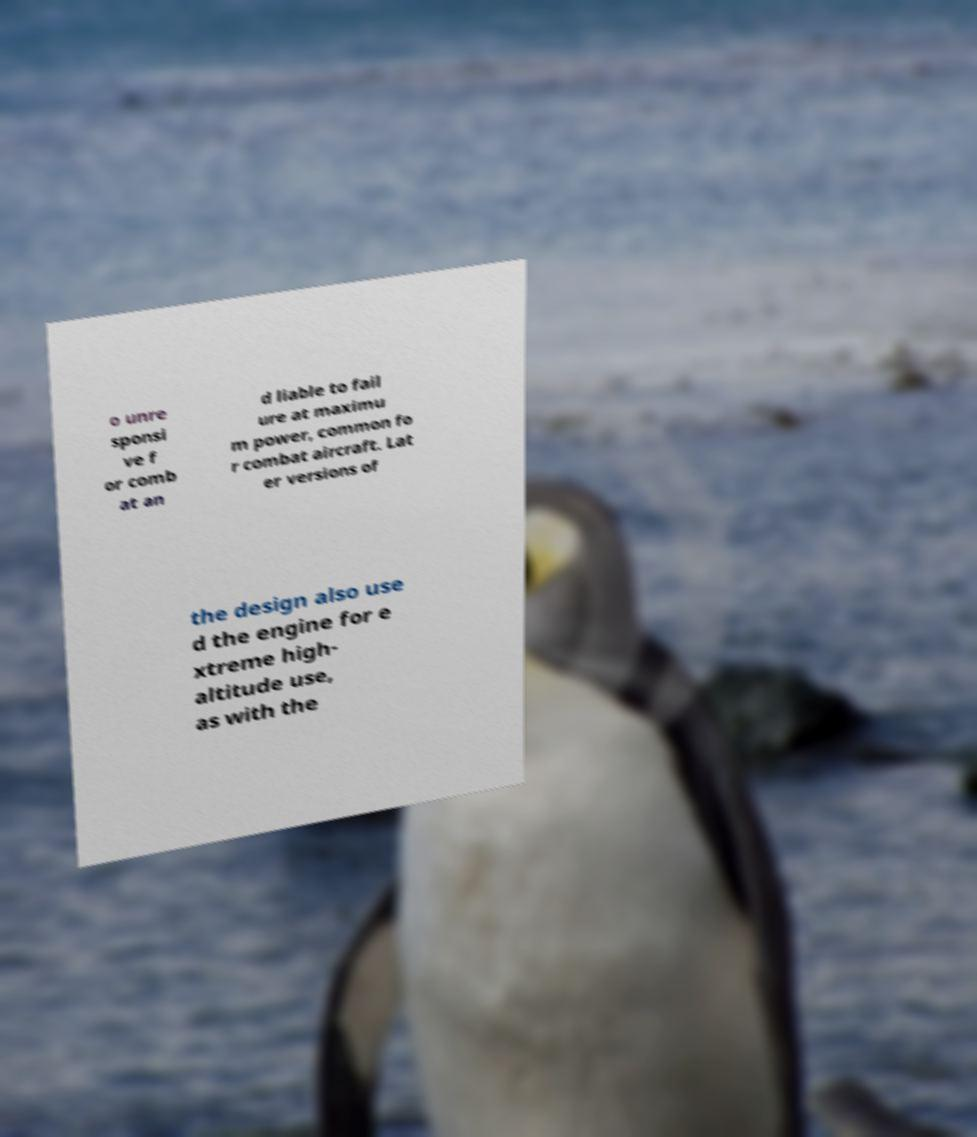Can you accurately transcribe the text from the provided image for me? o unre sponsi ve f or comb at an d liable to fail ure at maximu m power, common fo r combat aircraft. Lat er versions of the design also use d the engine for e xtreme high- altitude use, as with the 